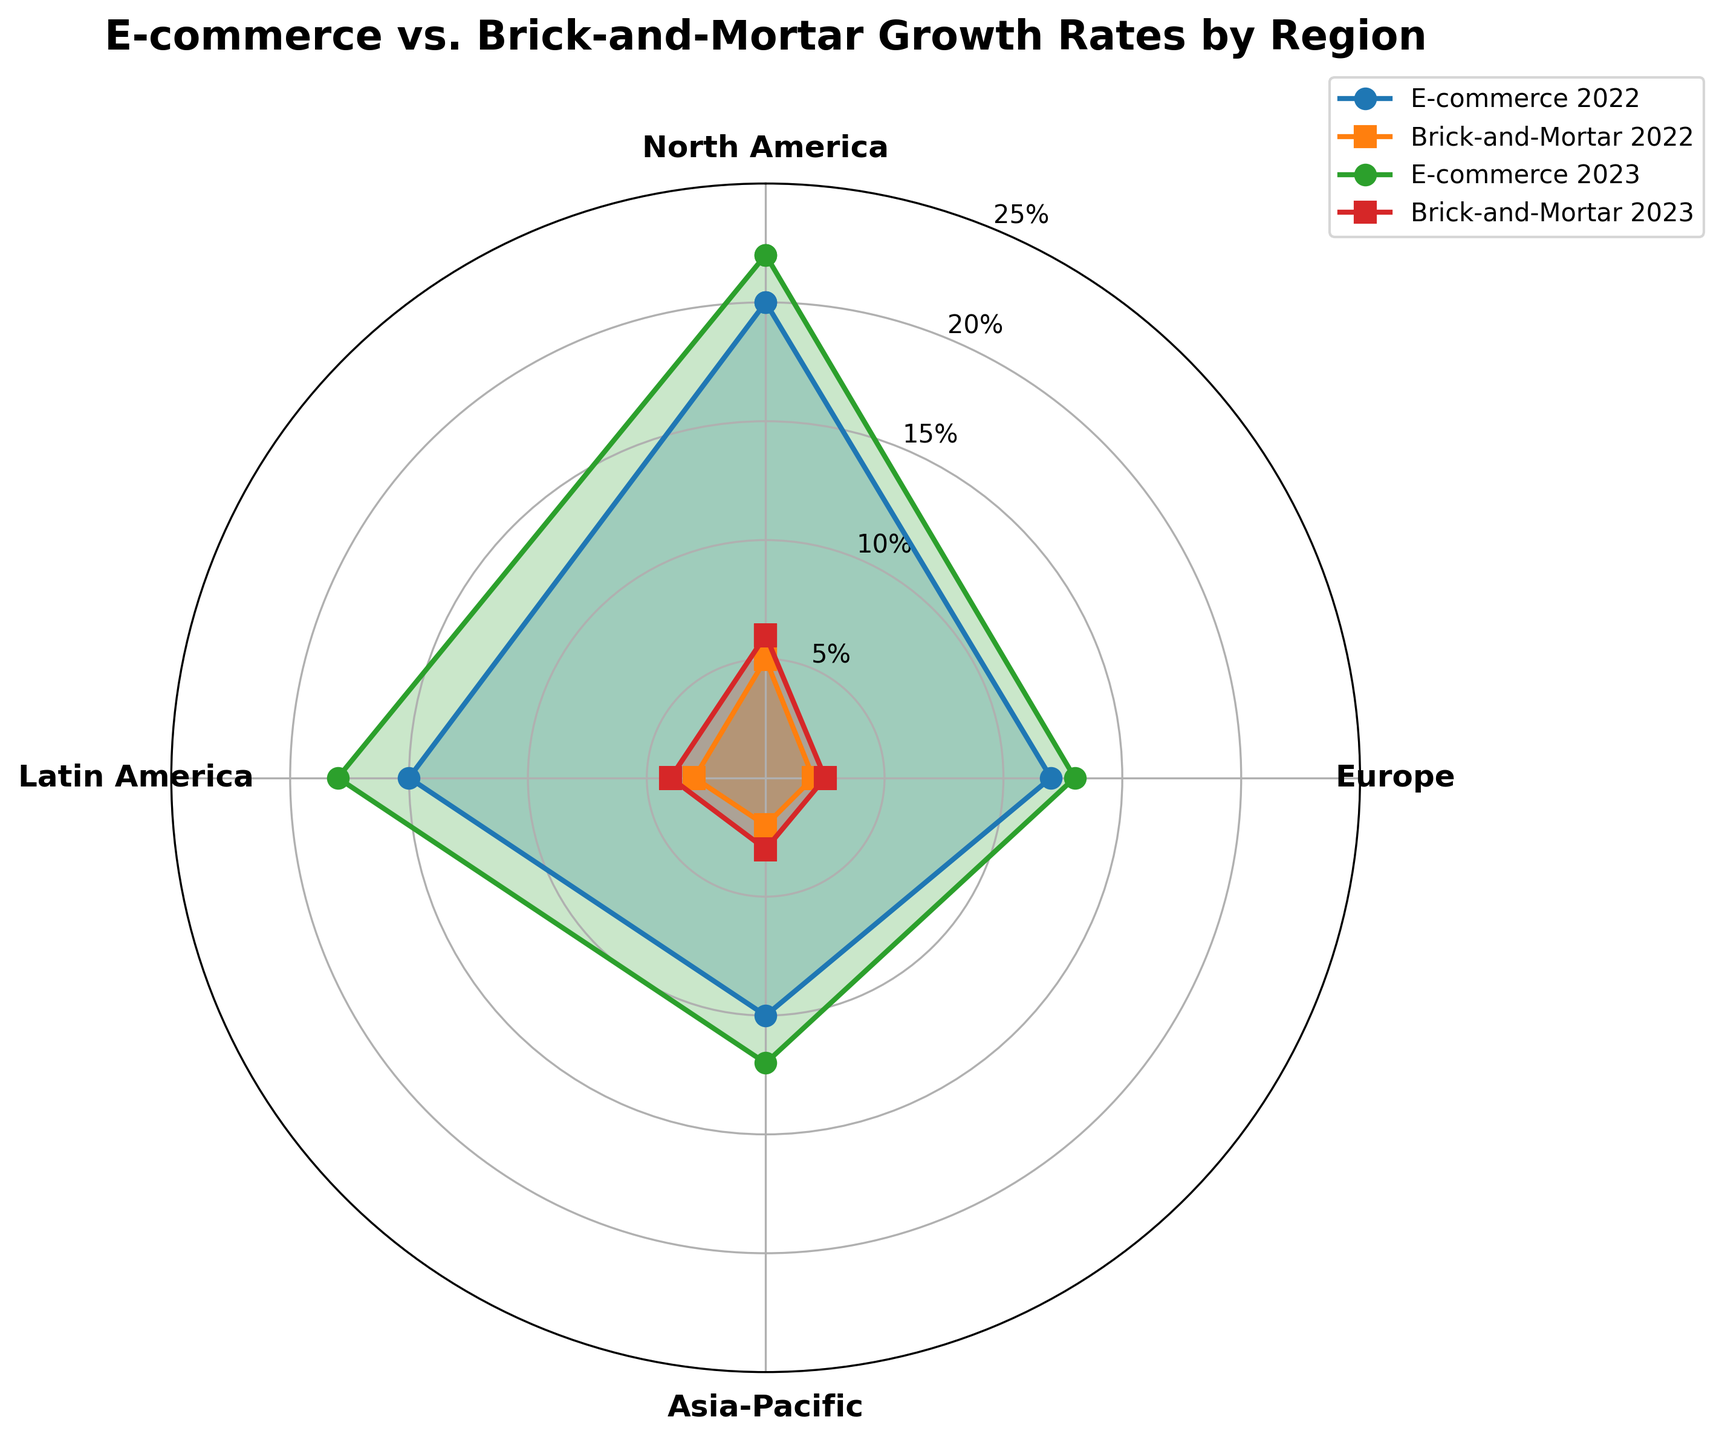What is the growth rate of E-commerce in North America for the year 2023? The radar chart shows different growth rates for each year and region. Find North America and look at the E-commerce growth rate for 2023.
Answer: 18% Which region had the highest E-commerce growth rate in 2022? Compare the E-commerce growth rates for all regions in 2022. Asia-Pacific stands out as having the highest growth rate.
Answer: Asia-Pacific Did the growth rate of Brick-and-Mortar stores in Europe increase or decrease from 2022 to 2023? Look at the Brick-and-Mortar growth rates in Europe for both 2022 and 2023. The rate increased from 2% to 2.5%.
Answer: Increase What is the difference between the E-commerce growth rates of Asia-Pacific and Latin America in 2023? Check the E-commerce growth rates for Asia-Pacific (22%) and Latin America (12%) for the year 2023. Subtract the Latin America rate from the Asia-Pacific rate to find the difference.
Answer: 10% Which region showed no change in Brick-and-Mortar growth rate between 2022 and 2023? Examine the Brick-and-Mortar growth rates for all regions for both years. Europe had the smallest change, increasing only from 2% to 2.5%.
Answer: None (smallest change in Europe) How does the E-commerce growth rate in Europe compare between 2022 and 2023? Look at the E-commerce growth rates for Europe in both 2022 and 2023, which increased from 12% to 13%.
Answer: Increased by 1% What is the average E-commerce growth rate for North America over the two years? Identify the E-commerce growth rates for North America for both years (15% for 2022 and 18% for 2023), then calculate the average: (15% + 18%) / 2 = 16.5%.
Answer: 16.5% Which store type had a higher growth rate in Latin America for 2023? Compare the growth rates for E-commerce (12%) and Brick-and-Mortar (3%) in Latin America for 2023. E-commerce had a higher rate.
Answer: E-commerce What is the overall trend in the E-commerce growth rate for the Asia-Pacific region between the two years? Look at the E-commerce growth rates for Asia-Pacific for both years. It increased from 20% in 2022 to 22% in 2023.
Answer: Increasing How much did the growth rate of Brick-and-Mortar stores increase on average across all regions from 2022 to 2023? Calculate the difference in growth rates for each region from 2022 to 2023 (North America: 1%, Europe: 0.5%, Asia-Pacific: 1%, Latin America: 1%). Average these differences: (1% + 0.5% + 1% + 1%) / 4 = 0.875%.
Answer: 0.875% 